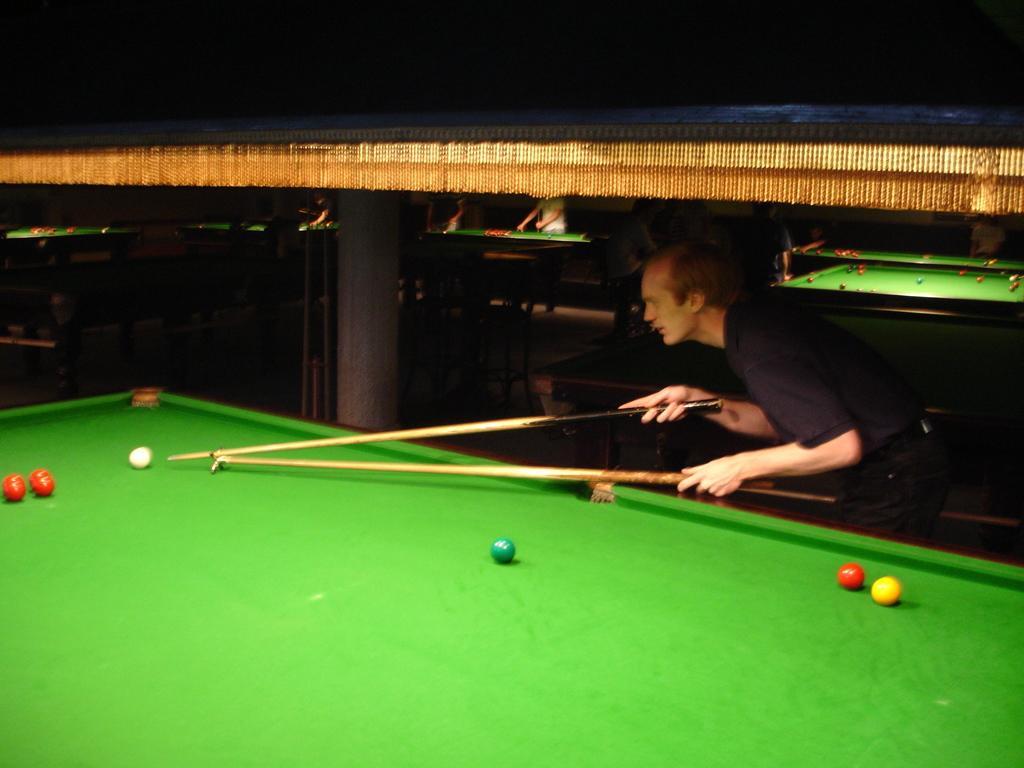In one or two sentences, can you explain what this image depicts? In this image In the right there is a man he is playing snooker game. In the middle there is a snooker table on that there are balls. In the back ground there are many tables and people are playing game. 